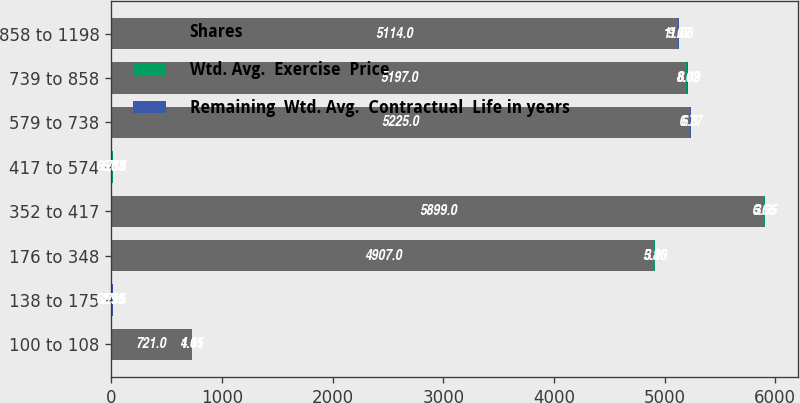<chart> <loc_0><loc_0><loc_500><loc_500><stacked_bar_chart><ecel><fcel>100 to 108<fcel>138 to 175<fcel>176 to 348<fcel>352 to 417<fcel>417 to 574<fcel>579 to 738<fcel>739 to 858<fcel>858 to 1198<nl><fcel>Shares<fcel>721<fcel>6.715<fcel>4907<fcel>5899<fcel>6.715<fcel>5225<fcel>5197<fcel>5114<nl><fcel>Wtd. Avg.  Exercise  Price<fcel>4.11<fcel>2.98<fcel>5.86<fcel>6.66<fcel>6.63<fcel>6.3<fcel>8.02<fcel>9.07<nl><fcel>Remaining  Wtd. Avg.  Contractual  Life in years<fcel>1.05<fcel>1.75<fcel>3.23<fcel>3.65<fcel>5.38<fcel>6.77<fcel>8.09<fcel>11.08<nl></chart> 